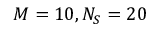Convert formula to latex. <formula><loc_0><loc_0><loc_500><loc_500>M = 1 0 , N _ { S } = 2 0</formula> 